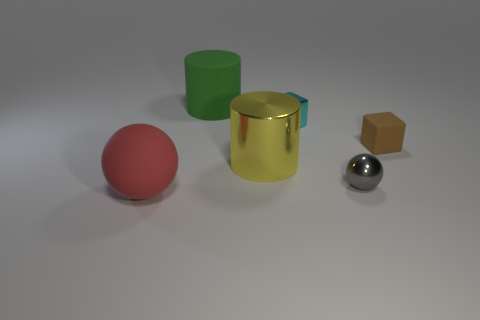Does the tiny matte cube have the same color as the shiny ball?
Offer a very short reply. No. What number of objects are in front of the cyan metallic thing and on the right side of the green cylinder?
Your response must be concise. 3. What number of brown objects are to the left of the small object that is behind the rubber object that is on the right side of the metallic cylinder?
Give a very brief answer. 0. What shape is the brown object?
Your response must be concise. Cube. How many cylinders are made of the same material as the small brown cube?
Offer a terse response. 1. There is a cylinder that is the same material as the gray object; what color is it?
Give a very brief answer. Yellow. There is a yellow object; does it have the same size as the metal ball that is to the left of the tiny matte cube?
Provide a short and direct response. No. There is a sphere that is behind the large rubber object that is on the left side of the cylinder that is behind the tiny cyan shiny object; what is it made of?
Your answer should be very brief. Metal. How many objects are big red rubber things or large cylinders?
Give a very brief answer. 3. There is a sphere behind the red rubber sphere; is it the same color as the cylinder that is behind the tiny cyan metallic thing?
Offer a terse response. No. 